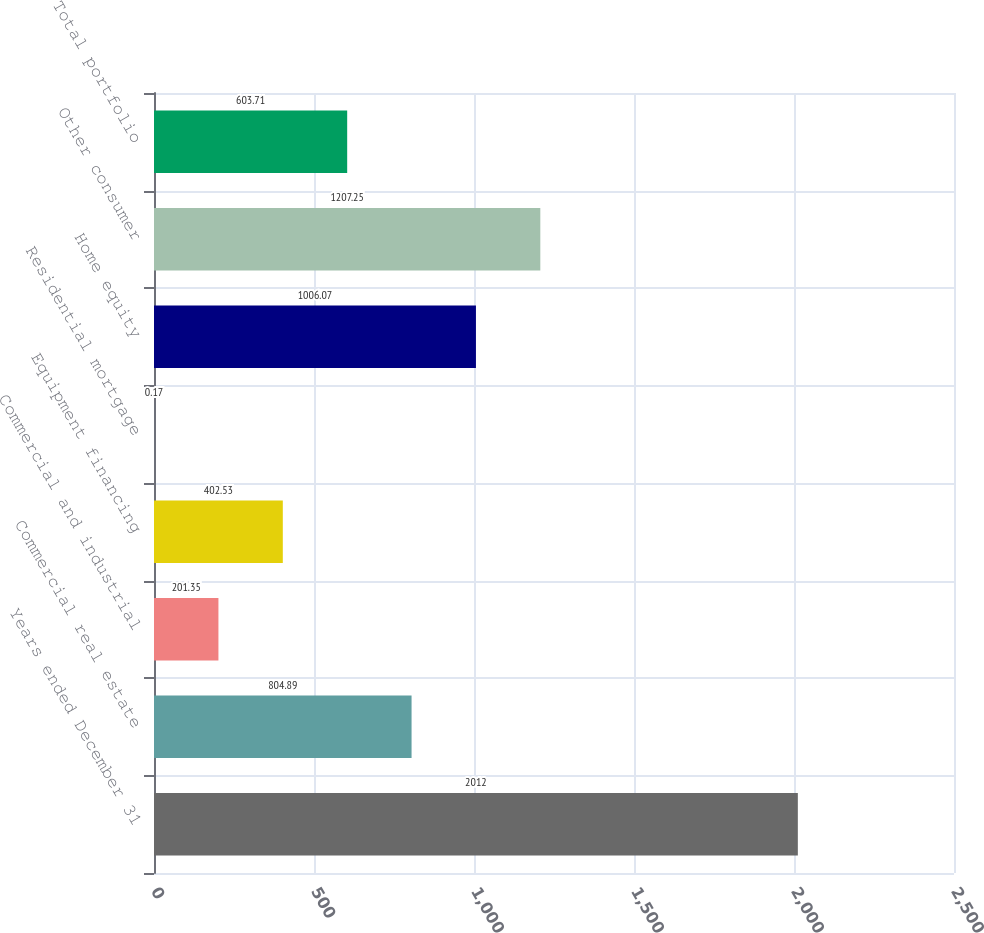Convert chart to OTSL. <chart><loc_0><loc_0><loc_500><loc_500><bar_chart><fcel>Years ended December 31<fcel>Commercial real estate<fcel>Commercial and industrial<fcel>Equipment financing<fcel>Residential mortgage<fcel>Home equity<fcel>Other consumer<fcel>Total portfolio<nl><fcel>2012<fcel>804.89<fcel>201.35<fcel>402.53<fcel>0.17<fcel>1006.07<fcel>1207.25<fcel>603.71<nl></chart> 